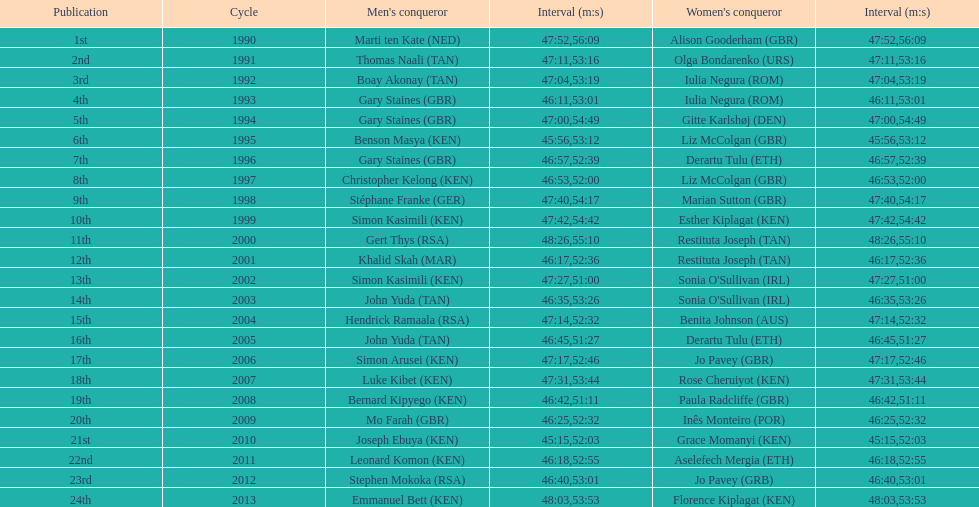Number of men's winners with a finish time under 46:58 12. Help me parse the entirety of this table. {'header': ['Publication', 'Cycle', "Men's conqueror", 'Interval (m:s)', "Women's conqueror", 'Interval (m:s)'], 'rows': [['1st', '1990', 'Marti ten Kate\xa0(NED)', '47:52', 'Alison Gooderham\xa0(GBR)', '56:09'], ['2nd', '1991', 'Thomas Naali\xa0(TAN)', '47:11', 'Olga Bondarenko\xa0(URS)', '53:16'], ['3rd', '1992', 'Boay Akonay\xa0(TAN)', '47:04', 'Iulia Negura\xa0(ROM)', '53:19'], ['4th', '1993', 'Gary Staines\xa0(GBR)', '46:11', 'Iulia Negura\xa0(ROM)', '53:01'], ['5th', '1994', 'Gary Staines\xa0(GBR)', '47:00', 'Gitte Karlshøj\xa0(DEN)', '54:49'], ['6th', '1995', 'Benson Masya\xa0(KEN)', '45:56', 'Liz McColgan\xa0(GBR)', '53:12'], ['7th', '1996', 'Gary Staines\xa0(GBR)', '46:57', 'Derartu Tulu\xa0(ETH)', '52:39'], ['8th', '1997', 'Christopher Kelong\xa0(KEN)', '46:53', 'Liz McColgan\xa0(GBR)', '52:00'], ['9th', '1998', 'Stéphane Franke\xa0(GER)', '47:40', 'Marian Sutton\xa0(GBR)', '54:17'], ['10th', '1999', 'Simon Kasimili\xa0(KEN)', '47:42', 'Esther Kiplagat\xa0(KEN)', '54:42'], ['11th', '2000', 'Gert Thys\xa0(RSA)', '48:26', 'Restituta Joseph\xa0(TAN)', '55:10'], ['12th', '2001', 'Khalid Skah\xa0(MAR)', '46:17', 'Restituta Joseph\xa0(TAN)', '52:36'], ['13th', '2002', 'Simon Kasimili\xa0(KEN)', '47:27', "Sonia O'Sullivan\xa0(IRL)", '51:00'], ['14th', '2003', 'John Yuda\xa0(TAN)', '46:35', "Sonia O'Sullivan\xa0(IRL)", '53:26'], ['15th', '2004', 'Hendrick Ramaala\xa0(RSA)', '47:14', 'Benita Johnson\xa0(AUS)', '52:32'], ['16th', '2005', 'John Yuda\xa0(TAN)', '46:45', 'Derartu Tulu\xa0(ETH)', '51:27'], ['17th', '2006', 'Simon Arusei\xa0(KEN)', '47:17', 'Jo Pavey\xa0(GBR)', '52:46'], ['18th', '2007', 'Luke Kibet\xa0(KEN)', '47:31', 'Rose Cheruiyot\xa0(KEN)', '53:44'], ['19th', '2008', 'Bernard Kipyego\xa0(KEN)', '46:42', 'Paula Radcliffe\xa0(GBR)', '51:11'], ['20th', '2009', 'Mo Farah\xa0(GBR)', '46:25', 'Inês Monteiro\xa0(POR)', '52:32'], ['21st', '2010', 'Joseph Ebuya\xa0(KEN)', '45:15', 'Grace Momanyi\xa0(KEN)', '52:03'], ['22nd', '2011', 'Leonard Komon\xa0(KEN)', '46:18', 'Aselefech Mergia\xa0(ETH)', '52:55'], ['23rd', '2012', 'Stephen Mokoka\xa0(RSA)', '46:40', 'Jo Pavey\xa0(GRB)', '53:01'], ['24th', '2013', 'Emmanuel Bett\xa0(KEN)', '48:03', 'Florence Kiplagat\xa0(KEN)', '53:53']]} 